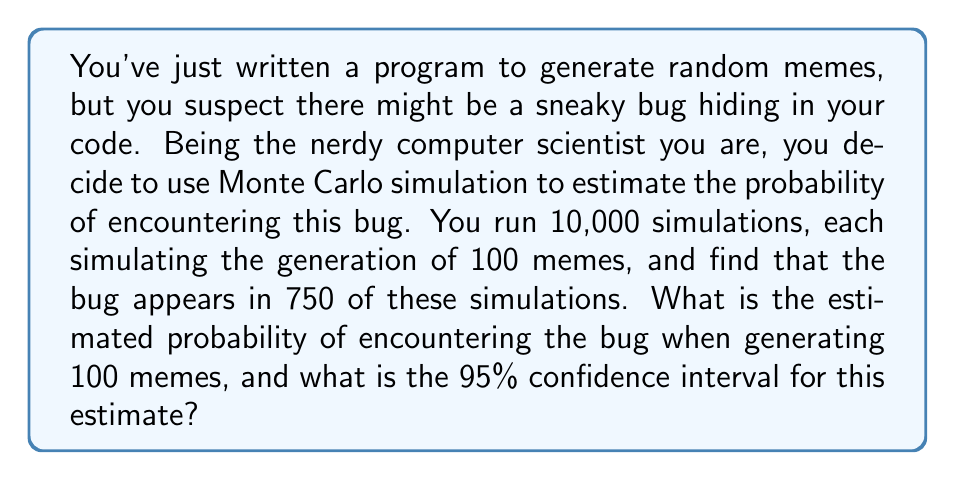Give your solution to this math problem. Let's approach this step-by-step:

1) The estimated probability (p) is simply the number of times the bug appeared divided by the total number of simulations:

   $p = \frac{750}{10000} = 0.075$ or 7.5%

2) To calculate the confidence interval, we'll use the normal approximation method. First, we need to calculate the standard error (SE):

   $SE = \sqrt{\frac{p(1-p)}{n}}$

   Where n is the number of simulations (10,000).

3) Plugging in our values:

   $SE = \sqrt{\frac{0.075(1-0.075)}{10000}} = \sqrt{\frac{0.069375}{10000}} = 0.002634$

4) For a 95% confidence interval, we use 1.96 as our z-score. The formula is:

   $CI = p \pm (1.96 * SE)$

5) Calculating the lower and upper bounds:

   Lower bound: $0.075 - (1.96 * 0.002634) = 0.069837$
   Upper bound: $0.075 + (1.96 * 0.002634) = 0.080163$

6) Therefore, we can say with 95% confidence that the true probability of encountering the bug when generating 100 memes is between 6.98% and 8.02%.

As a computer scientist with a love for nerdy humor, you might appreciate that this method is like trying to debug your code by repeatedly poking it with a stick and seeing how often it squeals.
Answer: 7.5% (95% CI: 6.98% - 8.02%) 